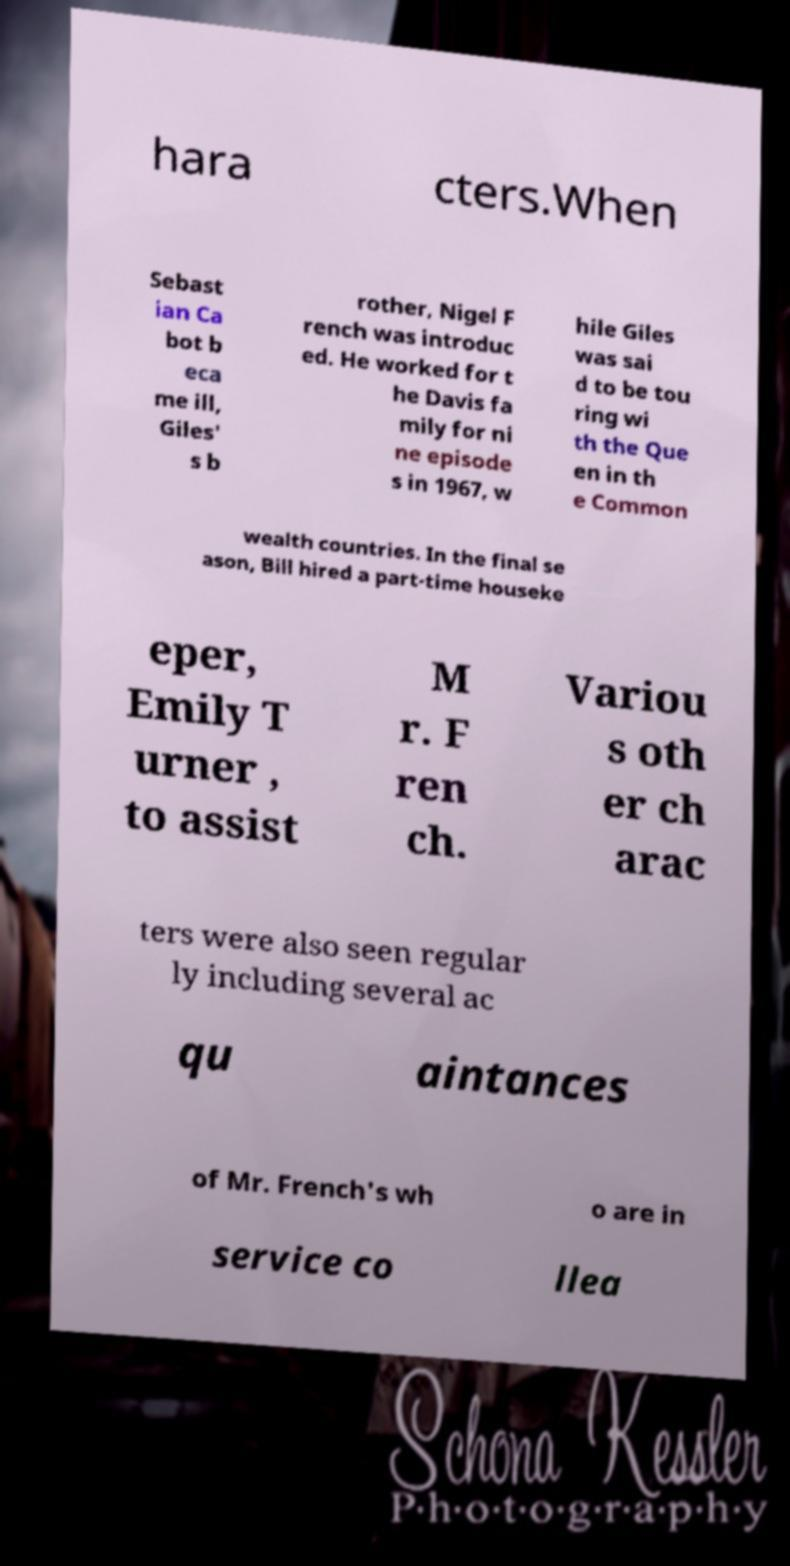For documentation purposes, I need the text within this image transcribed. Could you provide that? hara cters.When Sebast ian Ca bot b eca me ill, Giles' s b rother, Nigel F rench was introduc ed. He worked for t he Davis fa mily for ni ne episode s in 1967, w hile Giles was sai d to be tou ring wi th the Que en in th e Common wealth countries. In the final se ason, Bill hired a part-time houseke eper, Emily T urner , to assist M r. F ren ch. Variou s oth er ch arac ters were also seen regular ly including several ac qu aintances of Mr. French's wh o are in service co llea 